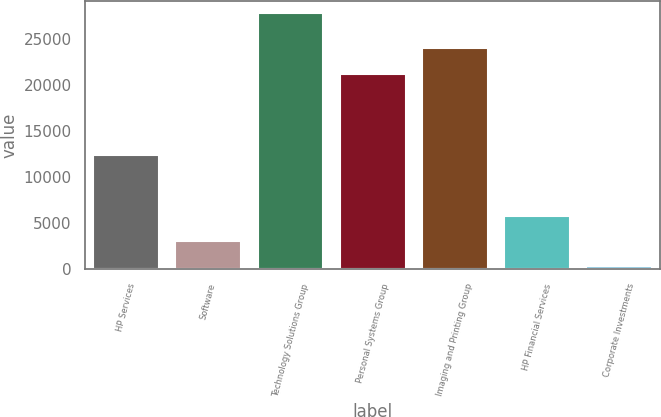<chart> <loc_0><loc_0><loc_500><loc_500><bar_chart><fcel>HP Services<fcel>Software<fcel>Technology Solutions Group<fcel>Personal Systems Group<fcel>Imaging and Printing Group<fcel>HP Financial Services<fcel>Corporate Investments<nl><fcel>12357<fcel>3082<fcel>27724<fcel>21210<fcel>23948<fcel>5820<fcel>344<nl></chart> 